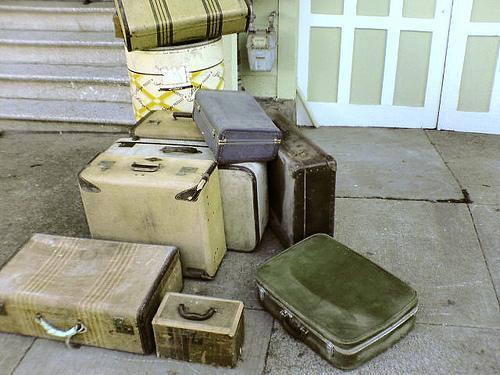How many suitcases are green?
Give a very brief answer. 1. How many suitcases are pictured?
Give a very brief answer. 10. How many pieces of luggage?
Give a very brief answer. 10. How many suitcases are visible?
Give a very brief answer. 8. 